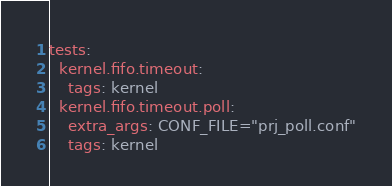Convert code to text. <code><loc_0><loc_0><loc_500><loc_500><_YAML_>tests:
  kernel.fifo.timeout:
    tags: kernel
  kernel.fifo.timeout.poll:
    extra_args: CONF_FILE="prj_poll.conf"
    tags: kernel
</code> 